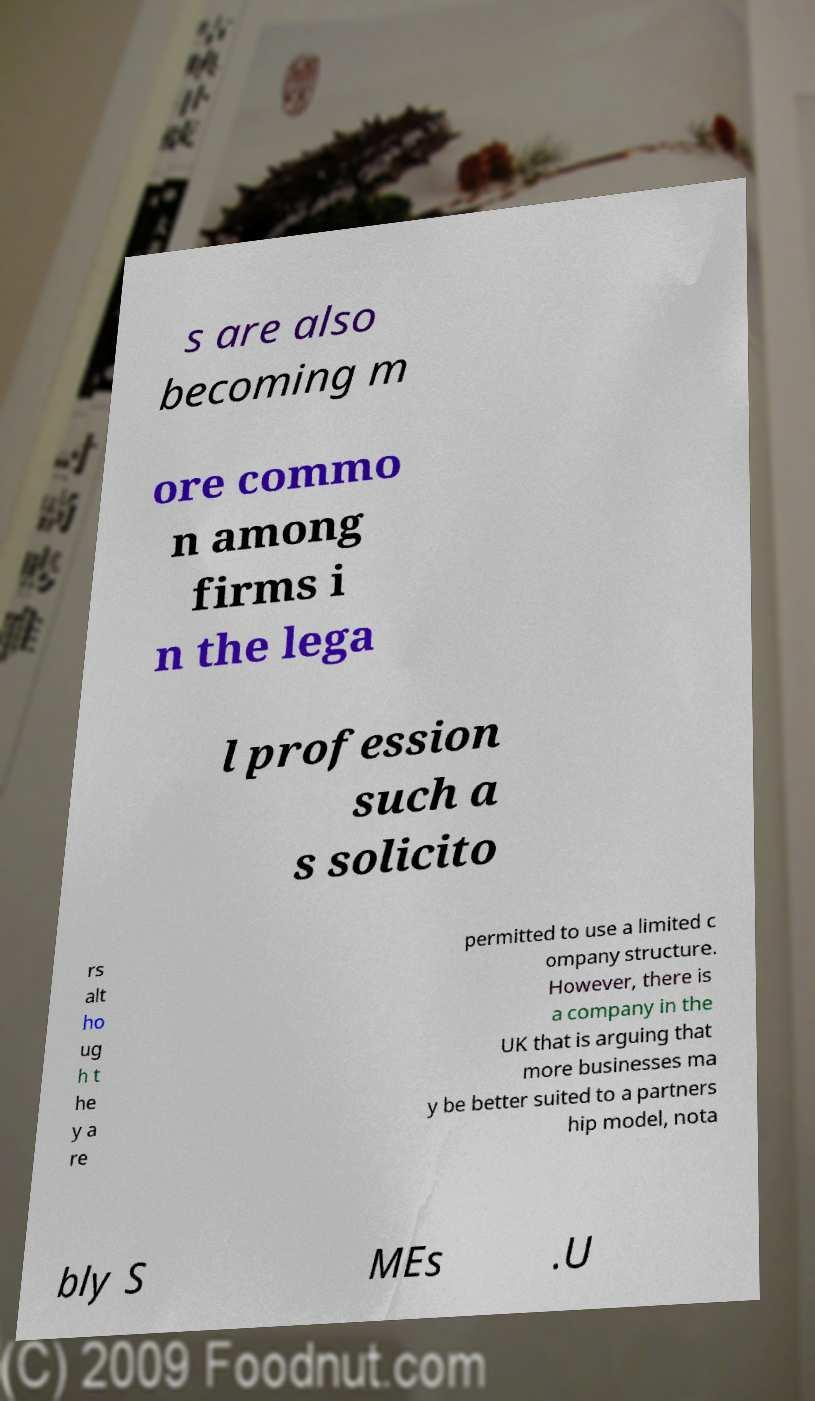Can you accurately transcribe the text from the provided image for me? s are also becoming m ore commo n among firms i n the lega l profession such a s solicito rs alt ho ug h t he y a re permitted to use a limited c ompany structure. However, there is a company in the UK that is arguing that more businesses ma y be better suited to a partners hip model, nota bly S MEs .U 